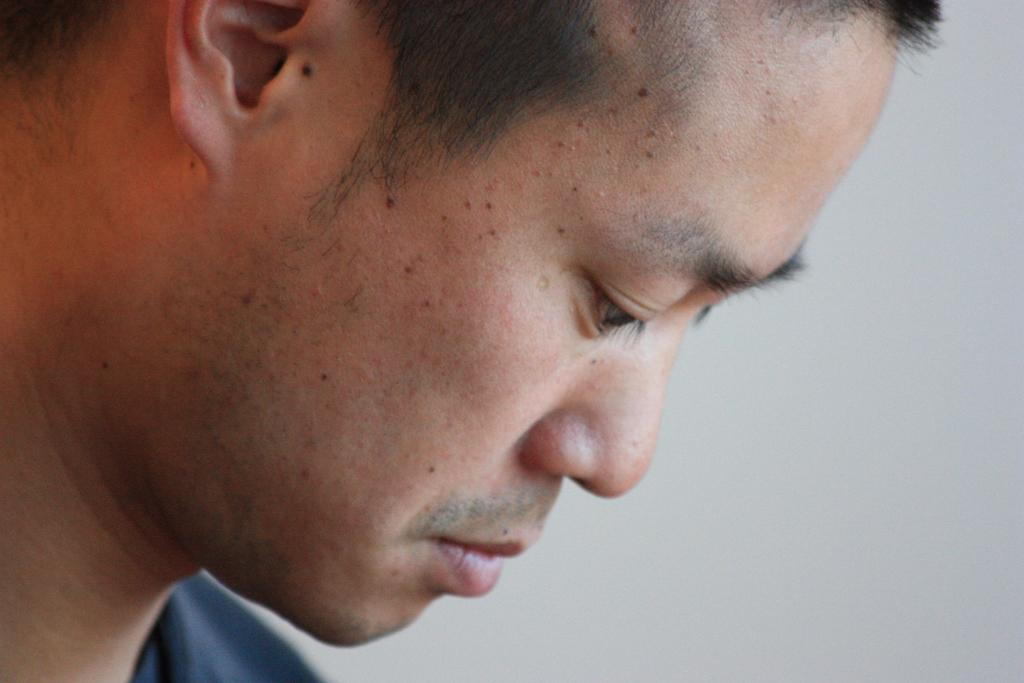Who or what is present in the image? There is a person in the image. What can be seen in the background of the image? There is a wall in the background of the image. What type of train can be seen in the image? There is no train present in the image; it only features a person and a wall in the background. 